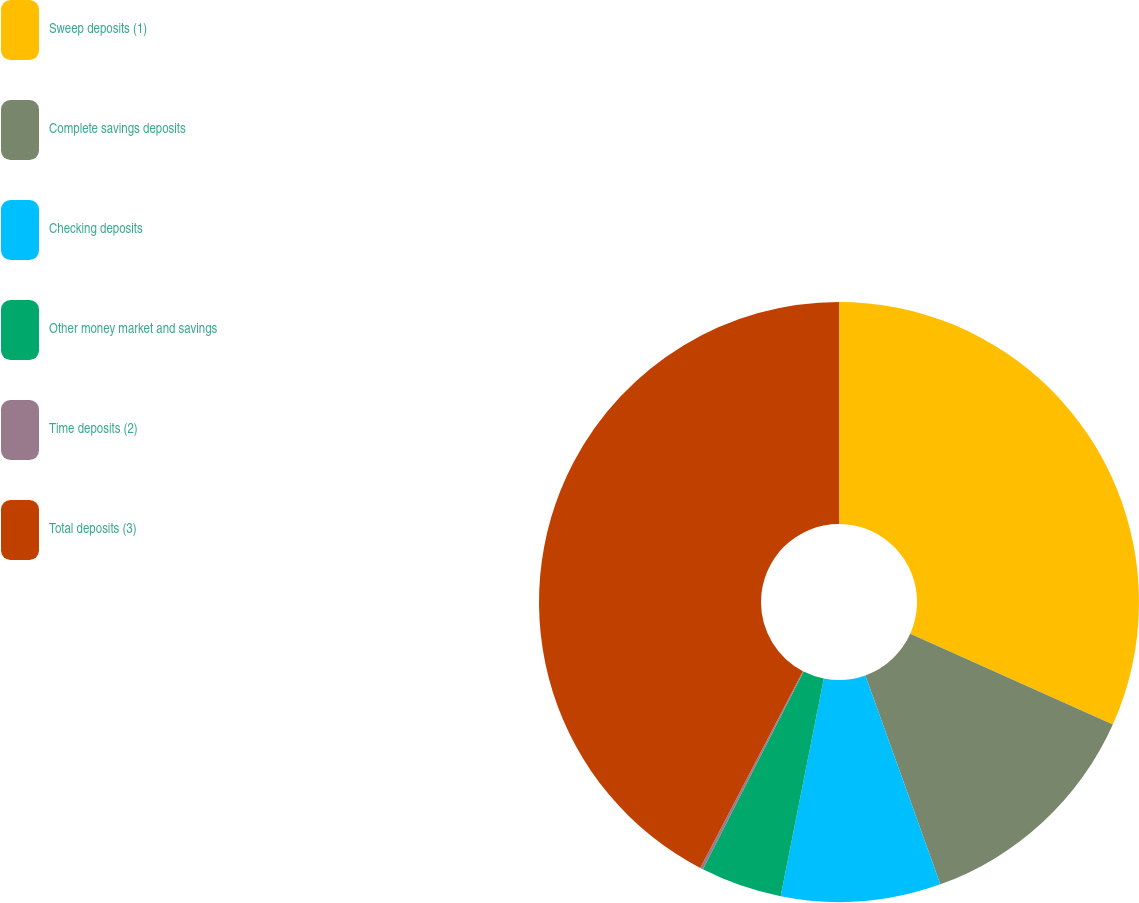<chart> <loc_0><loc_0><loc_500><loc_500><pie_chart><fcel>Sweep deposits (1)<fcel>Complete savings deposits<fcel>Checking deposits<fcel>Other money market and savings<fcel>Time deposits (2)<fcel>Total deposits (3)<nl><fcel>31.7%<fcel>12.82%<fcel>8.6%<fcel>4.38%<fcel>0.16%<fcel>42.35%<nl></chart> 